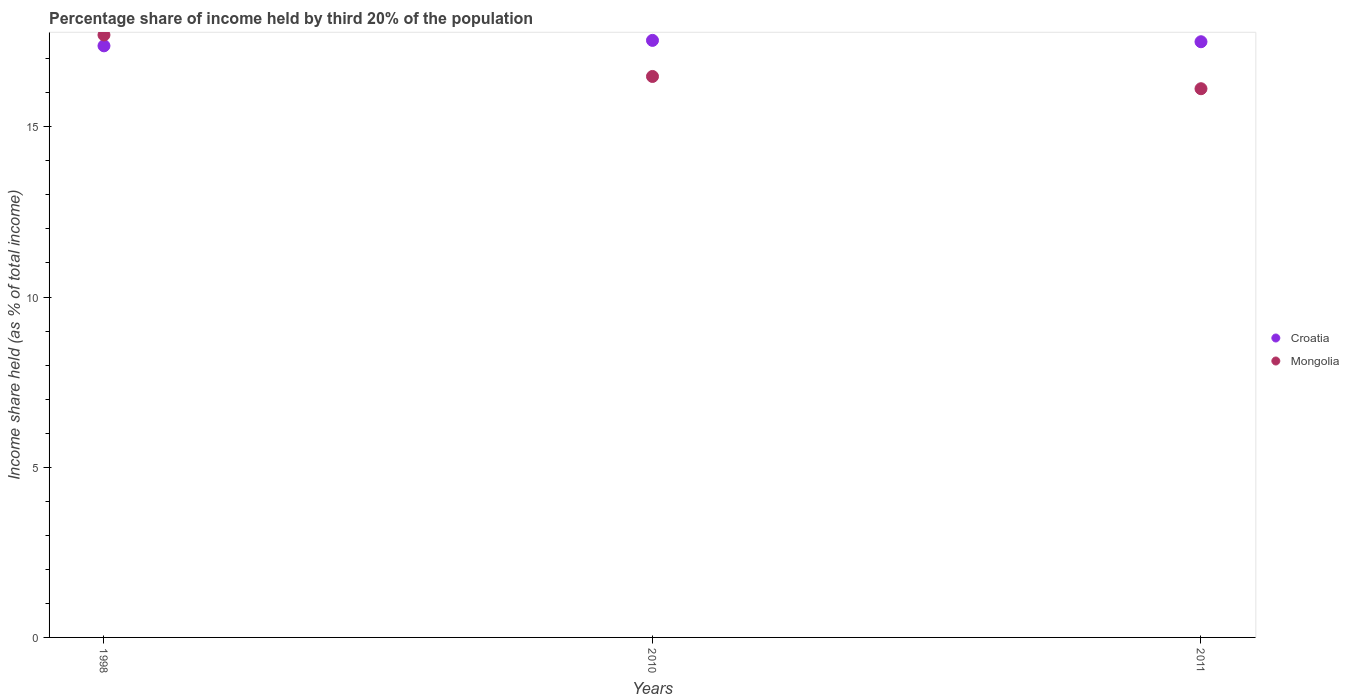How many different coloured dotlines are there?
Your response must be concise. 2. What is the share of income held by third 20% of the population in Croatia in 1998?
Your response must be concise. 17.38. Across all years, what is the minimum share of income held by third 20% of the population in Mongolia?
Keep it short and to the point. 16.12. In which year was the share of income held by third 20% of the population in Croatia minimum?
Your answer should be compact. 1998. What is the total share of income held by third 20% of the population in Croatia in the graph?
Your answer should be compact. 52.42. What is the difference between the share of income held by third 20% of the population in Croatia in 1998 and that in 2011?
Your response must be concise. -0.12. What is the difference between the share of income held by third 20% of the population in Croatia in 2011 and the share of income held by third 20% of the population in Mongolia in 2010?
Your answer should be very brief. 1.02. What is the average share of income held by third 20% of the population in Mongolia per year?
Make the answer very short. 16.77. In the year 2010, what is the difference between the share of income held by third 20% of the population in Mongolia and share of income held by third 20% of the population in Croatia?
Keep it short and to the point. -1.06. In how many years, is the share of income held by third 20% of the population in Mongolia greater than 16 %?
Keep it short and to the point. 3. What is the ratio of the share of income held by third 20% of the population in Mongolia in 2010 to that in 2011?
Ensure brevity in your answer.  1.02. Is the share of income held by third 20% of the population in Mongolia in 1998 less than that in 2010?
Give a very brief answer. No. Is the difference between the share of income held by third 20% of the population in Mongolia in 1998 and 2011 greater than the difference between the share of income held by third 20% of the population in Croatia in 1998 and 2011?
Your answer should be very brief. Yes. What is the difference between the highest and the second highest share of income held by third 20% of the population in Croatia?
Offer a very short reply. 0.04. What is the difference between the highest and the lowest share of income held by third 20% of the population in Croatia?
Ensure brevity in your answer.  0.16. In how many years, is the share of income held by third 20% of the population in Croatia greater than the average share of income held by third 20% of the population in Croatia taken over all years?
Give a very brief answer. 2. Does the share of income held by third 20% of the population in Croatia monotonically increase over the years?
Keep it short and to the point. No. Is the share of income held by third 20% of the population in Croatia strictly greater than the share of income held by third 20% of the population in Mongolia over the years?
Your response must be concise. No. Is the share of income held by third 20% of the population in Croatia strictly less than the share of income held by third 20% of the population in Mongolia over the years?
Ensure brevity in your answer.  No. Are the values on the major ticks of Y-axis written in scientific E-notation?
Ensure brevity in your answer.  No. Does the graph contain any zero values?
Your answer should be very brief. No. What is the title of the graph?
Ensure brevity in your answer.  Percentage share of income held by third 20% of the population. Does "Turkey" appear as one of the legend labels in the graph?
Provide a succinct answer. No. What is the label or title of the X-axis?
Your answer should be compact. Years. What is the label or title of the Y-axis?
Your answer should be very brief. Income share held (as % of total income). What is the Income share held (as % of total income) in Croatia in 1998?
Give a very brief answer. 17.38. What is the Income share held (as % of total income) of Croatia in 2010?
Offer a terse response. 17.54. What is the Income share held (as % of total income) of Mongolia in 2010?
Your answer should be very brief. 16.48. What is the Income share held (as % of total income) in Croatia in 2011?
Give a very brief answer. 17.5. What is the Income share held (as % of total income) in Mongolia in 2011?
Your answer should be very brief. 16.12. Across all years, what is the maximum Income share held (as % of total income) in Croatia?
Offer a terse response. 17.54. Across all years, what is the minimum Income share held (as % of total income) of Croatia?
Provide a short and direct response. 17.38. Across all years, what is the minimum Income share held (as % of total income) of Mongolia?
Ensure brevity in your answer.  16.12. What is the total Income share held (as % of total income) of Croatia in the graph?
Ensure brevity in your answer.  52.42. What is the total Income share held (as % of total income) in Mongolia in the graph?
Your response must be concise. 50.3. What is the difference between the Income share held (as % of total income) in Croatia in 1998 and that in 2010?
Ensure brevity in your answer.  -0.16. What is the difference between the Income share held (as % of total income) of Mongolia in 1998 and that in 2010?
Ensure brevity in your answer.  1.22. What is the difference between the Income share held (as % of total income) in Croatia in 1998 and that in 2011?
Provide a succinct answer. -0.12. What is the difference between the Income share held (as % of total income) of Mongolia in 1998 and that in 2011?
Make the answer very short. 1.58. What is the difference between the Income share held (as % of total income) of Croatia in 2010 and that in 2011?
Provide a short and direct response. 0.04. What is the difference between the Income share held (as % of total income) in Mongolia in 2010 and that in 2011?
Give a very brief answer. 0.36. What is the difference between the Income share held (as % of total income) of Croatia in 1998 and the Income share held (as % of total income) of Mongolia in 2011?
Keep it short and to the point. 1.26. What is the difference between the Income share held (as % of total income) of Croatia in 2010 and the Income share held (as % of total income) of Mongolia in 2011?
Offer a terse response. 1.42. What is the average Income share held (as % of total income) in Croatia per year?
Make the answer very short. 17.47. What is the average Income share held (as % of total income) in Mongolia per year?
Keep it short and to the point. 16.77. In the year 1998, what is the difference between the Income share held (as % of total income) in Croatia and Income share held (as % of total income) in Mongolia?
Make the answer very short. -0.32. In the year 2010, what is the difference between the Income share held (as % of total income) of Croatia and Income share held (as % of total income) of Mongolia?
Your answer should be compact. 1.06. In the year 2011, what is the difference between the Income share held (as % of total income) in Croatia and Income share held (as % of total income) in Mongolia?
Keep it short and to the point. 1.38. What is the ratio of the Income share held (as % of total income) in Croatia in 1998 to that in 2010?
Provide a succinct answer. 0.99. What is the ratio of the Income share held (as % of total income) in Mongolia in 1998 to that in 2010?
Your answer should be very brief. 1.07. What is the ratio of the Income share held (as % of total income) in Croatia in 1998 to that in 2011?
Your response must be concise. 0.99. What is the ratio of the Income share held (as % of total income) in Mongolia in 1998 to that in 2011?
Give a very brief answer. 1.1. What is the ratio of the Income share held (as % of total income) in Croatia in 2010 to that in 2011?
Offer a terse response. 1. What is the ratio of the Income share held (as % of total income) in Mongolia in 2010 to that in 2011?
Your answer should be very brief. 1.02. What is the difference between the highest and the second highest Income share held (as % of total income) in Croatia?
Provide a succinct answer. 0.04. What is the difference between the highest and the second highest Income share held (as % of total income) of Mongolia?
Your response must be concise. 1.22. What is the difference between the highest and the lowest Income share held (as % of total income) of Croatia?
Make the answer very short. 0.16. What is the difference between the highest and the lowest Income share held (as % of total income) in Mongolia?
Provide a succinct answer. 1.58. 